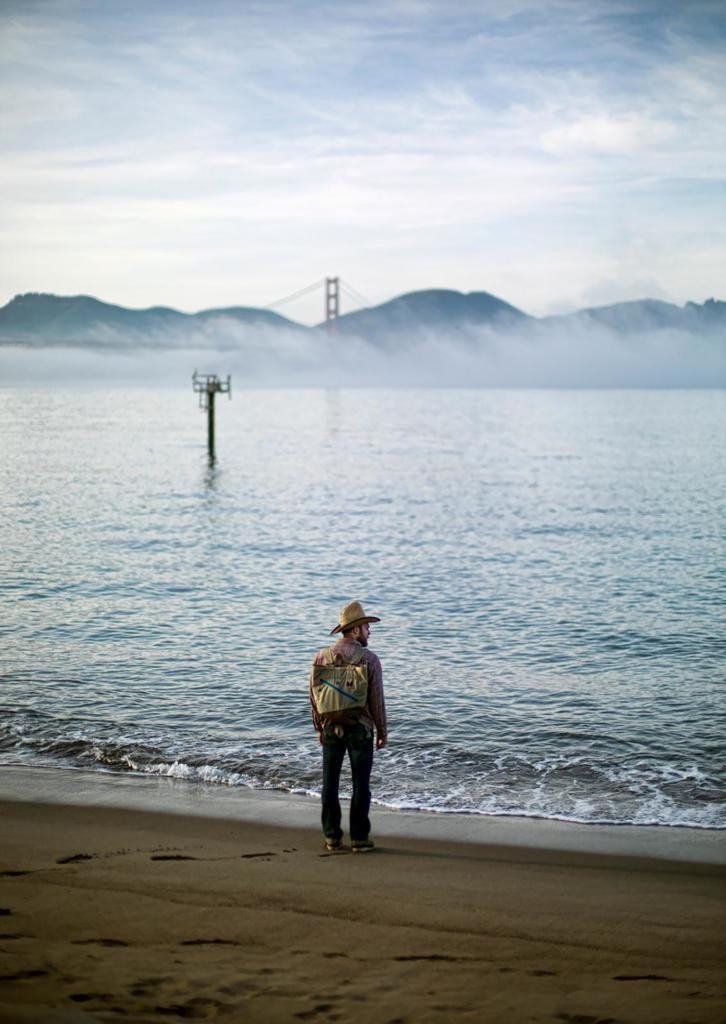What is the main subject of the image? There is a person in the image. Where is the person located in the image? The person is on the ground. What can be seen in the background of the image? There is water, poles, mountains, and the sky visible in the background of the image. What type of lumber is being used to build the tank in the image? There is no tank or lumber present in the image. 